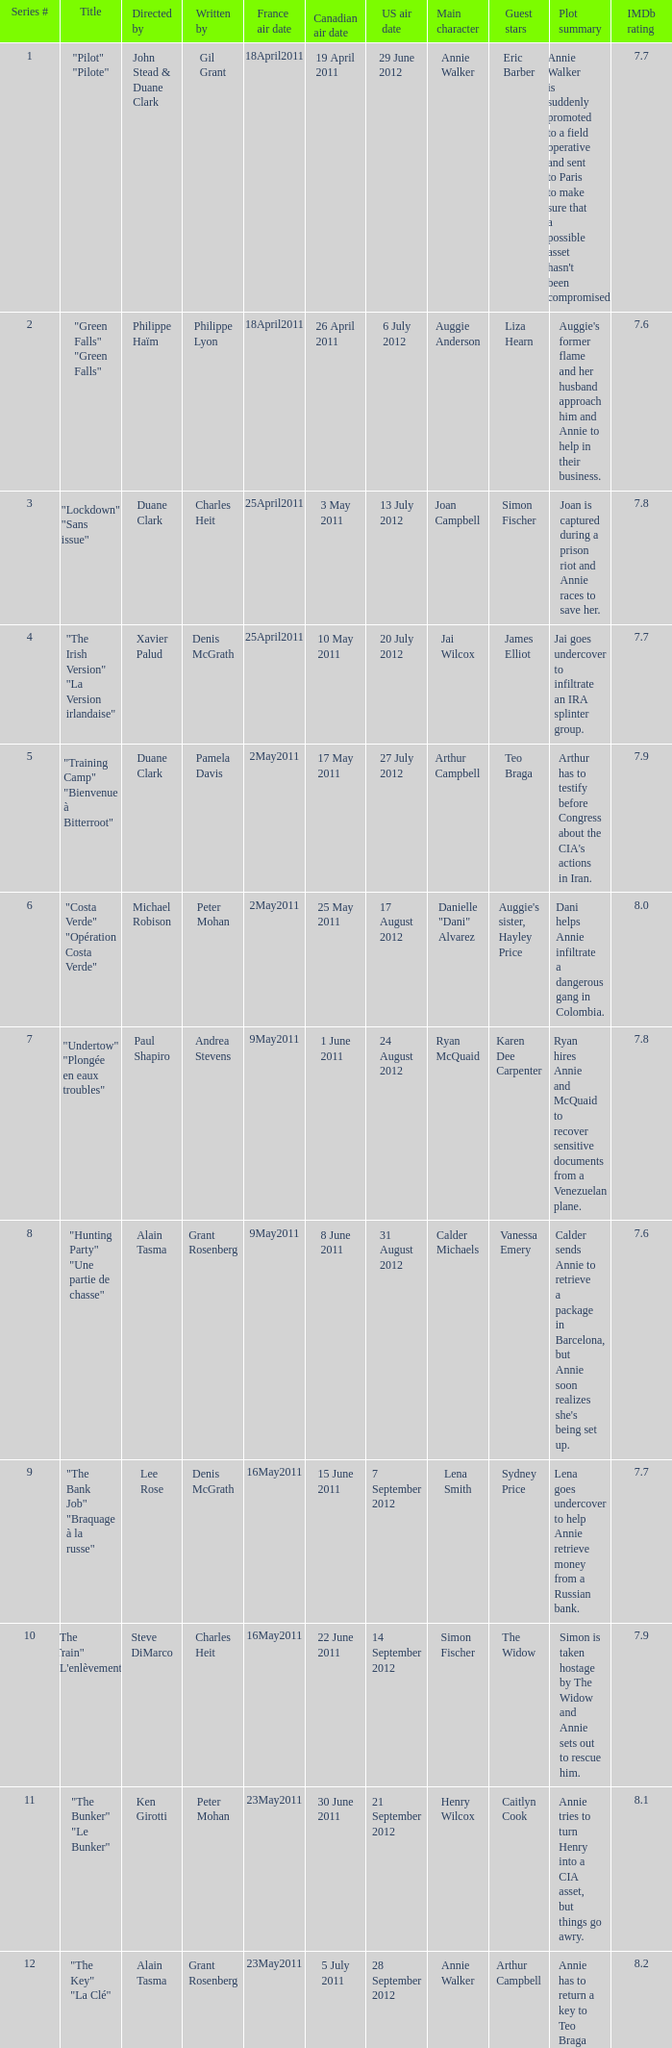What is the US air date when the director is ken girotti? 21 September 2012. 